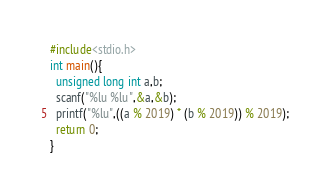<code> <loc_0><loc_0><loc_500><loc_500><_C_>#include<stdio.h>
int main(){
  unsigned long int a,b;
  scanf("%lu %lu",&a,&b);
  printf("%lu",((a % 2019) * (b % 2019)) % 2019);
  return 0;
}</code> 